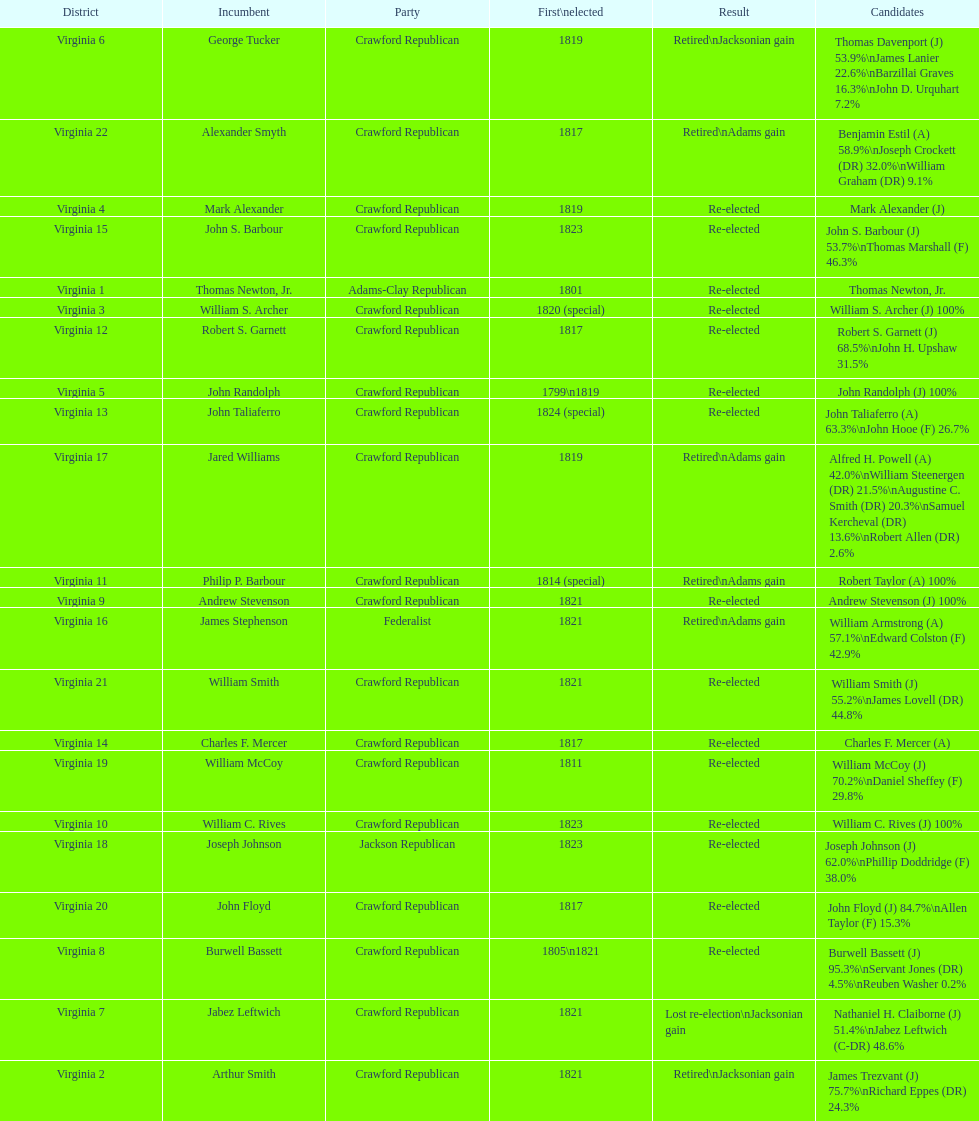Who was the next incumbent after john randolph? George Tucker. 